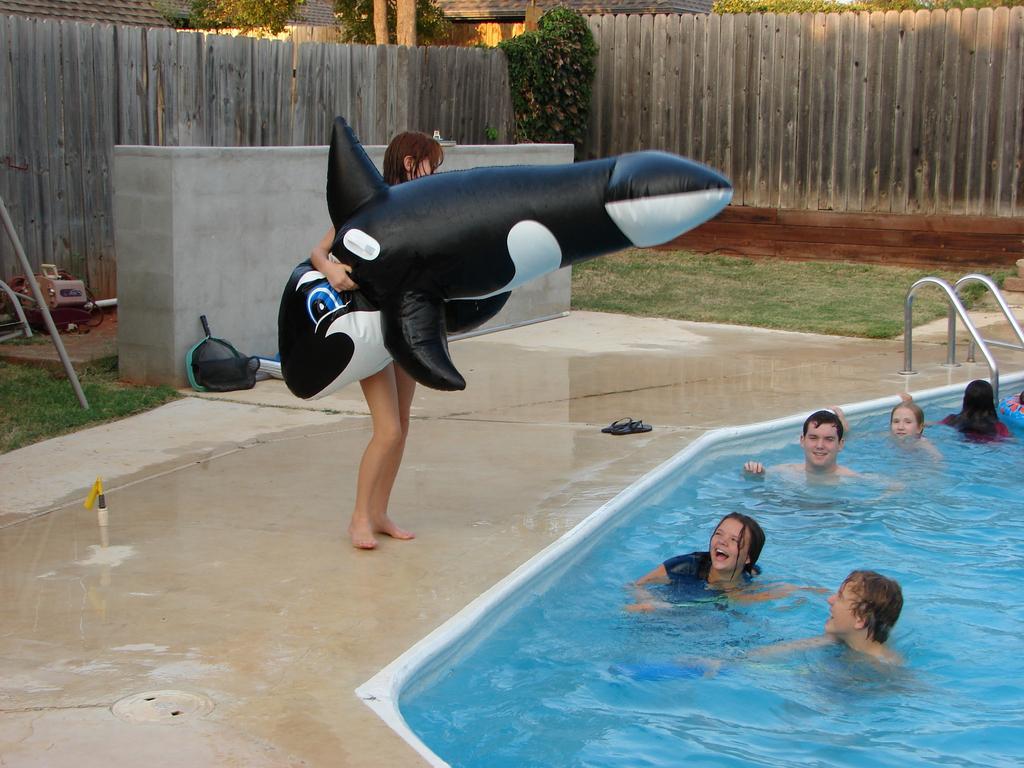Please provide a concise description of this image. In this image there is a wooden wall, green grass, trees in the left corner. There is a person holding an object in the foreground. There is a swimming pool with water and people in the right bottom corner. There is a wooden wall and trees in the background. 